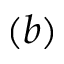Convert formula to latex. <formula><loc_0><loc_0><loc_500><loc_500>( b )</formula> 